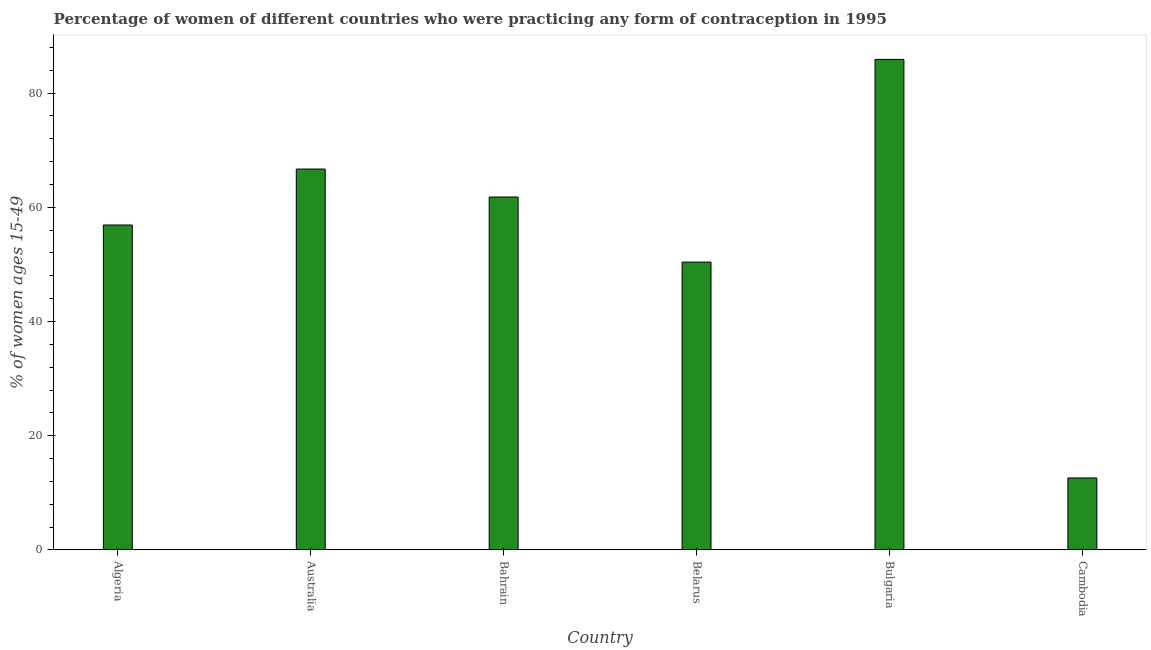What is the title of the graph?
Make the answer very short. Percentage of women of different countries who were practicing any form of contraception in 1995. What is the label or title of the Y-axis?
Your response must be concise. % of women ages 15-49. What is the contraceptive prevalence in Bulgaria?
Your response must be concise. 85.9. Across all countries, what is the maximum contraceptive prevalence?
Your answer should be compact. 85.9. Across all countries, what is the minimum contraceptive prevalence?
Your response must be concise. 12.6. In which country was the contraceptive prevalence minimum?
Give a very brief answer. Cambodia. What is the sum of the contraceptive prevalence?
Your response must be concise. 334.3. What is the difference between the contraceptive prevalence in Bahrain and Bulgaria?
Provide a short and direct response. -24.1. What is the average contraceptive prevalence per country?
Provide a short and direct response. 55.72. What is the median contraceptive prevalence?
Offer a very short reply. 59.35. In how many countries, is the contraceptive prevalence greater than 84 %?
Make the answer very short. 1. What is the ratio of the contraceptive prevalence in Bahrain to that in Belarus?
Offer a very short reply. 1.23. Is the contraceptive prevalence in Bulgaria less than that in Cambodia?
Keep it short and to the point. No. Is the difference between the contraceptive prevalence in Bahrain and Bulgaria greater than the difference between any two countries?
Ensure brevity in your answer.  No. What is the difference between the highest and the second highest contraceptive prevalence?
Offer a terse response. 19.2. Is the sum of the contraceptive prevalence in Belarus and Cambodia greater than the maximum contraceptive prevalence across all countries?
Provide a succinct answer. No. What is the difference between the highest and the lowest contraceptive prevalence?
Your response must be concise. 73.3. In how many countries, is the contraceptive prevalence greater than the average contraceptive prevalence taken over all countries?
Ensure brevity in your answer.  4. How many bars are there?
Keep it short and to the point. 6. Are all the bars in the graph horizontal?
Offer a terse response. No. What is the % of women ages 15-49 of Algeria?
Your answer should be very brief. 56.9. What is the % of women ages 15-49 in Australia?
Give a very brief answer. 66.7. What is the % of women ages 15-49 in Bahrain?
Your response must be concise. 61.8. What is the % of women ages 15-49 in Belarus?
Provide a short and direct response. 50.4. What is the % of women ages 15-49 of Bulgaria?
Offer a terse response. 85.9. What is the difference between the % of women ages 15-49 in Algeria and Australia?
Provide a short and direct response. -9.8. What is the difference between the % of women ages 15-49 in Algeria and Bahrain?
Give a very brief answer. -4.9. What is the difference between the % of women ages 15-49 in Algeria and Cambodia?
Make the answer very short. 44.3. What is the difference between the % of women ages 15-49 in Australia and Bulgaria?
Ensure brevity in your answer.  -19.2. What is the difference between the % of women ages 15-49 in Australia and Cambodia?
Your answer should be compact. 54.1. What is the difference between the % of women ages 15-49 in Bahrain and Bulgaria?
Offer a very short reply. -24.1. What is the difference between the % of women ages 15-49 in Bahrain and Cambodia?
Make the answer very short. 49.2. What is the difference between the % of women ages 15-49 in Belarus and Bulgaria?
Keep it short and to the point. -35.5. What is the difference between the % of women ages 15-49 in Belarus and Cambodia?
Provide a short and direct response. 37.8. What is the difference between the % of women ages 15-49 in Bulgaria and Cambodia?
Keep it short and to the point. 73.3. What is the ratio of the % of women ages 15-49 in Algeria to that in Australia?
Offer a very short reply. 0.85. What is the ratio of the % of women ages 15-49 in Algeria to that in Bahrain?
Ensure brevity in your answer.  0.92. What is the ratio of the % of women ages 15-49 in Algeria to that in Belarus?
Your answer should be compact. 1.13. What is the ratio of the % of women ages 15-49 in Algeria to that in Bulgaria?
Make the answer very short. 0.66. What is the ratio of the % of women ages 15-49 in Algeria to that in Cambodia?
Your response must be concise. 4.52. What is the ratio of the % of women ages 15-49 in Australia to that in Bahrain?
Keep it short and to the point. 1.08. What is the ratio of the % of women ages 15-49 in Australia to that in Belarus?
Make the answer very short. 1.32. What is the ratio of the % of women ages 15-49 in Australia to that in Bulgaria?
Your answer should be very brief. 0.78. What is the ratio of the % of women ages 15-49 in Australia to that in Cambodia?
Offer a terse response. 5.29. What is the ratio of the % of women ages 15-49 in Bahrain to that in Belarus?
Give a very brief answer. 1.23. What is the ratio of the % of women ages 15-49 in Bahrain to that in Bulgaria?
Keep it short and to the point. 0.72. What is the ratio of the % of women ages 15-49 in Bahrain to that in Cambodia?
Offer a terse response. 4.91. What is the ratio of the % of women ages 15-49 in Belarus to that in Bulgaria?
Your answer should be compact. 0.59. What is the ratio of the % of women ages 15-49 in Bulgaria to that in Cambodia?
Make the answer very short. 6.82. 